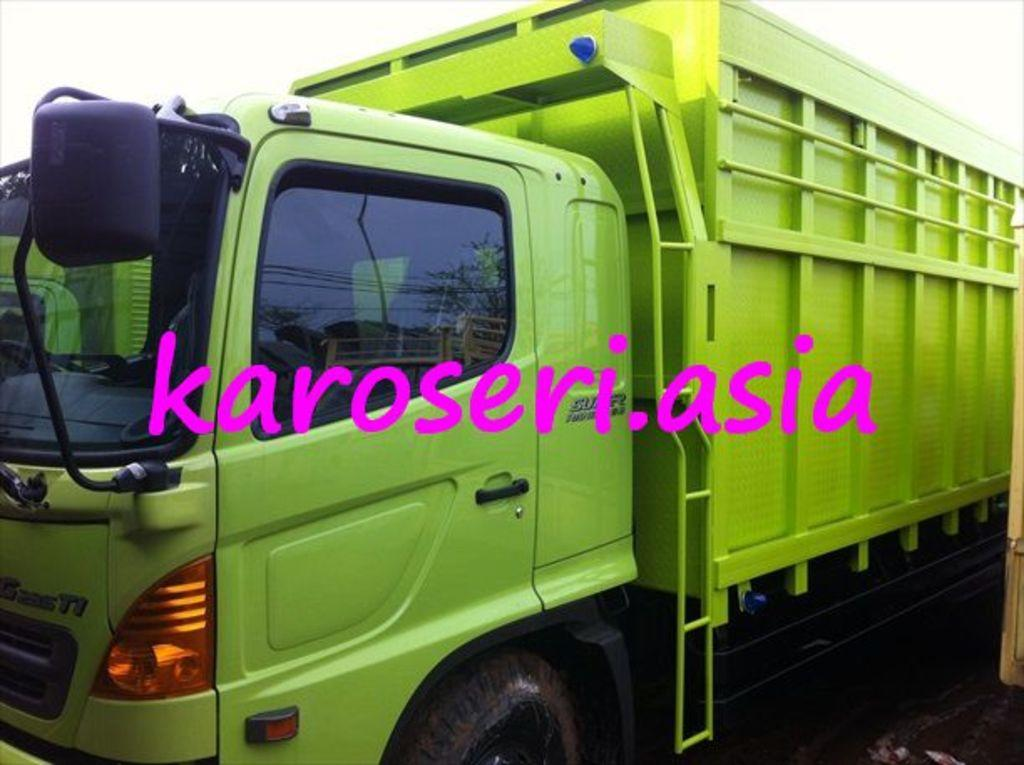What is the main subject of the image? There is a vehicle in the image. Can you describe the color of the vehicle? The vehicle is green in color. What else can be seen in the image besides the vehicle? The sky is visible at the top of the image. What news story is being discussed by the people in the image? There are no people present in the image, and therefore no news story can be discussed. 